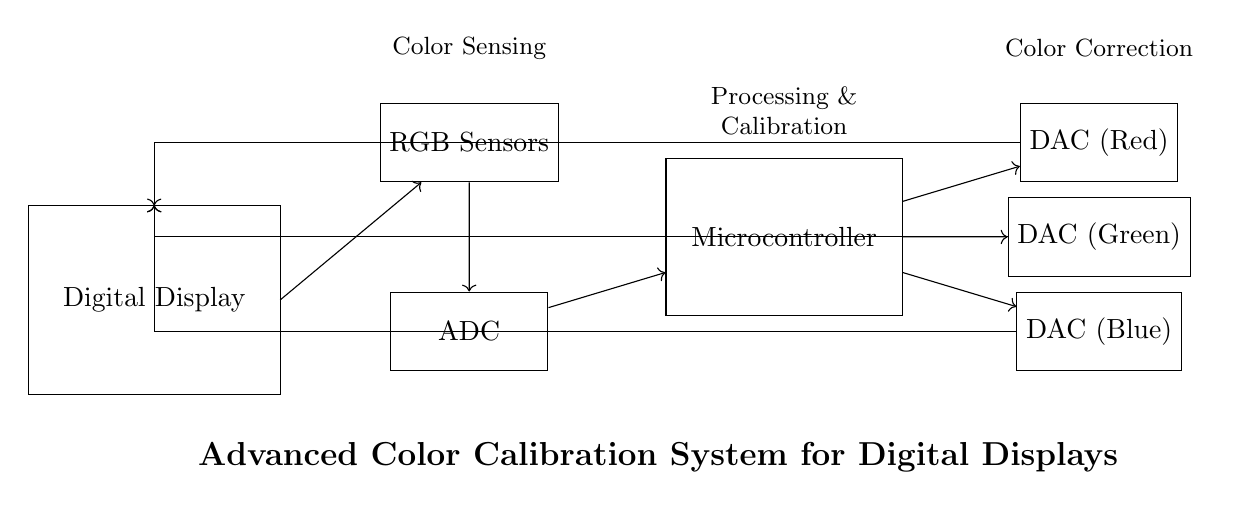What type of sensors are used in this system? The circuit diagram indicates that RGB sensors are employed for color sensing. This is visually represented by the labeled rectangle that reads "RGB Sensors."
Answer: RGB sensors How many DACs are present in the system? There are three DACs shown in the diagram, specifically labeled as DAC (Red), DAC (Green), and DAC (Blue). This confirms the presence of three separate digital-to-analog converters.
Answer: Three What is the role of the microcontroller? The microcontroller, indicated in the diagram, processes the input from the ADC and sends control signals to the DACs for color correction. This function is derived from its labeled role in the processing and calibration block connected to other components.
Answer: Processing and calibration Which components are directly receiving input from the ADC? The components receiving input from the ADC are the microcontroller and subsequently, the DACs (Red, Green, Blue). This is derived from the arrows indicating directional flow from the ADC to the microcontroller, which then directs to all three DACs.
Answer: Microcontroller Explain the flow of signals in the circuit. The signal flow starts from the RGB Sensors, which provide color data to the ADC for digitization. The digitized data is then sent to the microcontroller for processing and calibration, and finally, the microcontroller outputs signals to the DACs for correcting the colors. This is traced by following the arrows connecting all relevant components in sequence.
Answer: RGB Sensors -> ADC -> Microcontroller -> DACs 